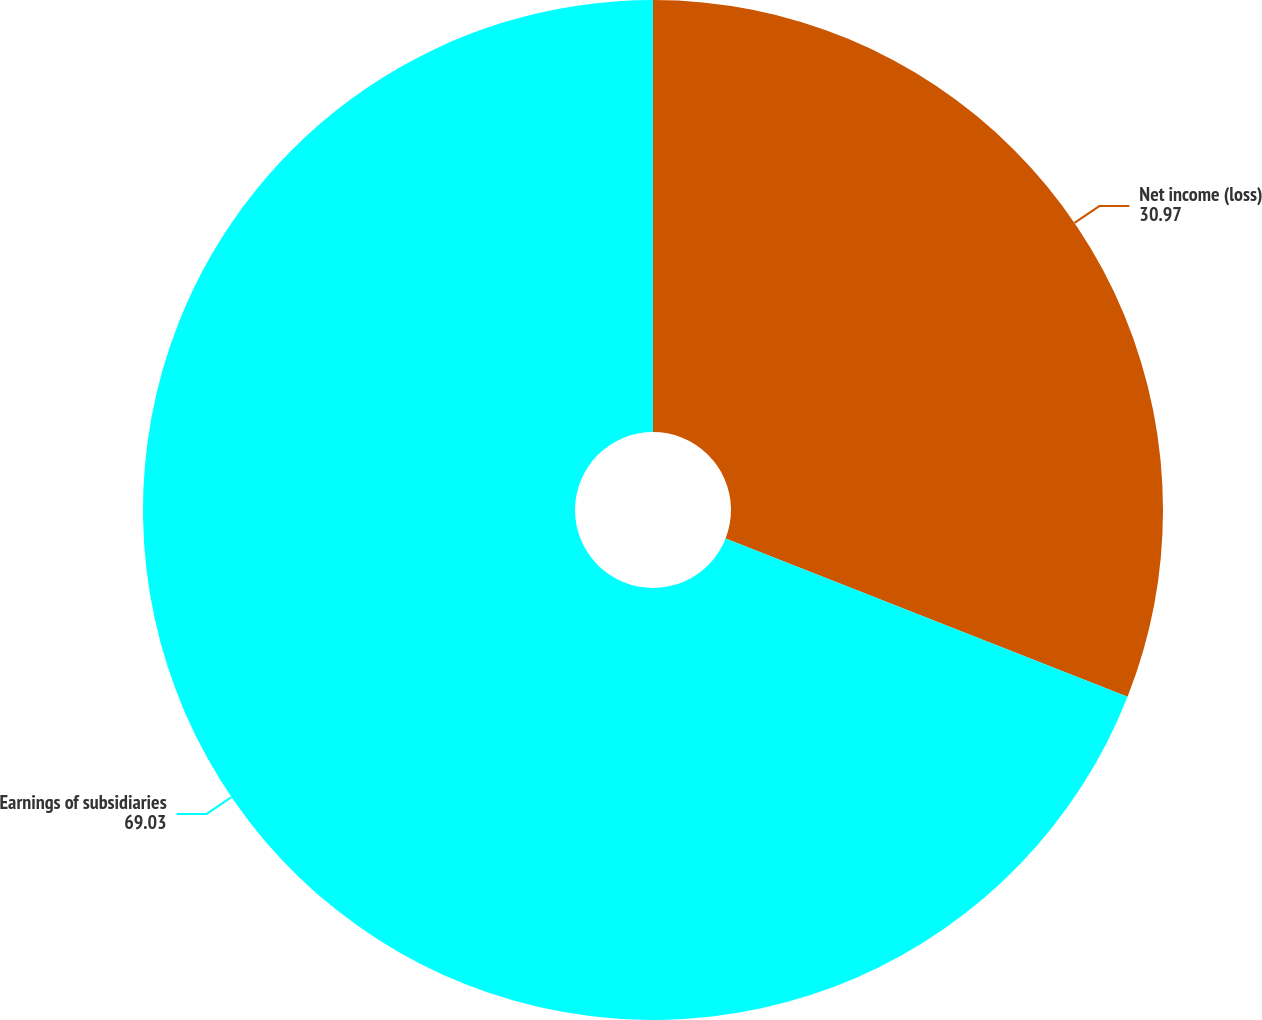Convert chart. <chart><loc_0><loc_0><loc_500><loc_500><pie_chart><fcel>Net income (loss)<fcel>Earnings of subsidiaries<nl><fcel>30.97%<fcel>69.03%<nl></chart> 